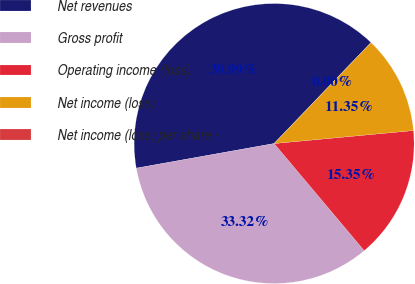<chart> <loc_0><loc_0><loc_500><loc_500><pie_chart><fcel>Net revenues<fcel>Gross profit<fcel>Operating income (loss)<fcel>Net income (loss)<fcel>Net income (loss) per share -<nl><fcel>39.99%<fcel>33.32%<fcel>15.35%<fcel>11.35%<fcel>0.0%<nl></chart> 